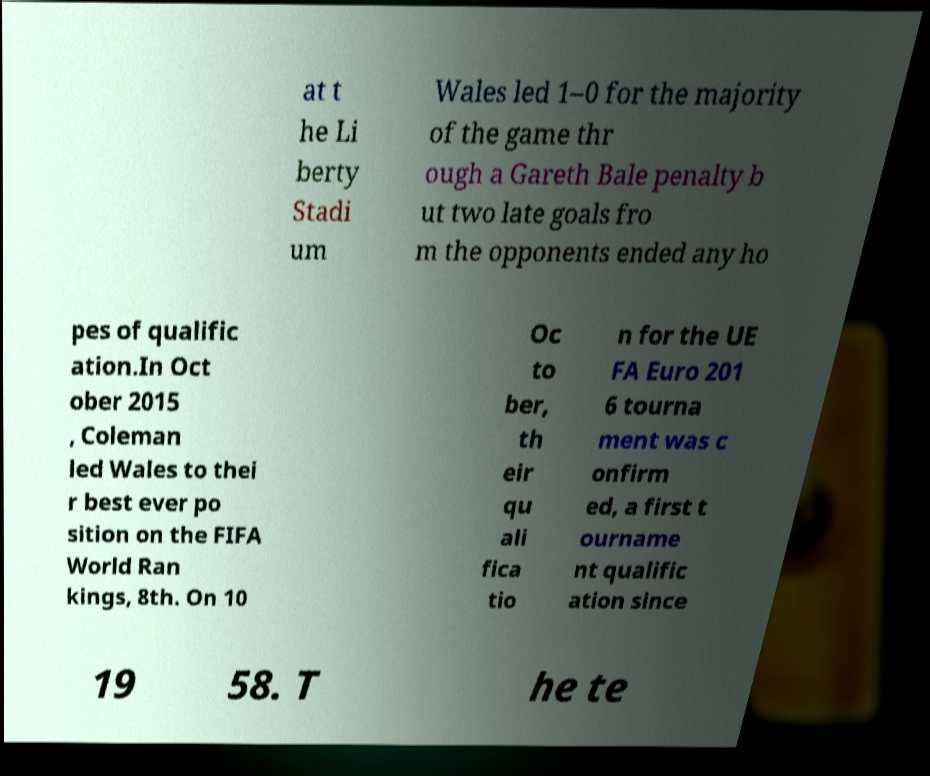For documentation purposes, I need the text within this image transcribed. Could you provide that? at t he Li berty Stadi um Wales led 1–0 for the majority of the game thr ough a Gareth Bale penalty b ut two late goals fro m the opponents ended any ho pes of qualific ation.In Oct ober 2015 , Coleman led Wales to thei r best ever po sition on the FIFA World Ran kings, 8th. On 10 Oc to ber, th eir qu ali fica tio n for the UE FA Euro 201 6 tourna ment was c onfirm ed, a first t ourname nt qualific ation since 19 58. T he te 